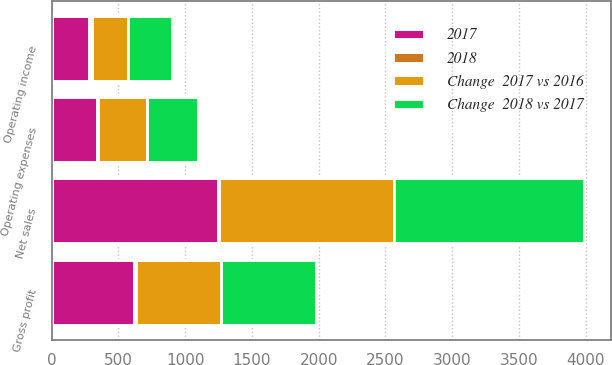Convert chart to OTSL. <chart><loc_0><loc_0><loc_500><loc_500><stacked_bar_chart><ecel><fcel>Net sales<fcel>Gross profit<fcel>Operating expenses<fcel>Operating income<nl><fcel>Change  2018 vs 2017<fcel>1423<fcel>710<fcel>385<fcel>325<nl><fcel>Change  2017 vs 2016<fcel>1311<fcel>640<fcel>366<fcel>274<nl><fcel>2017<fcel>1247<fcel>620<fcel>339<fcel>281<nl><fcel>2018<fcel>8.5<fcel>10.9<fcel>5.2<fcel>18.6<nl></chart> 